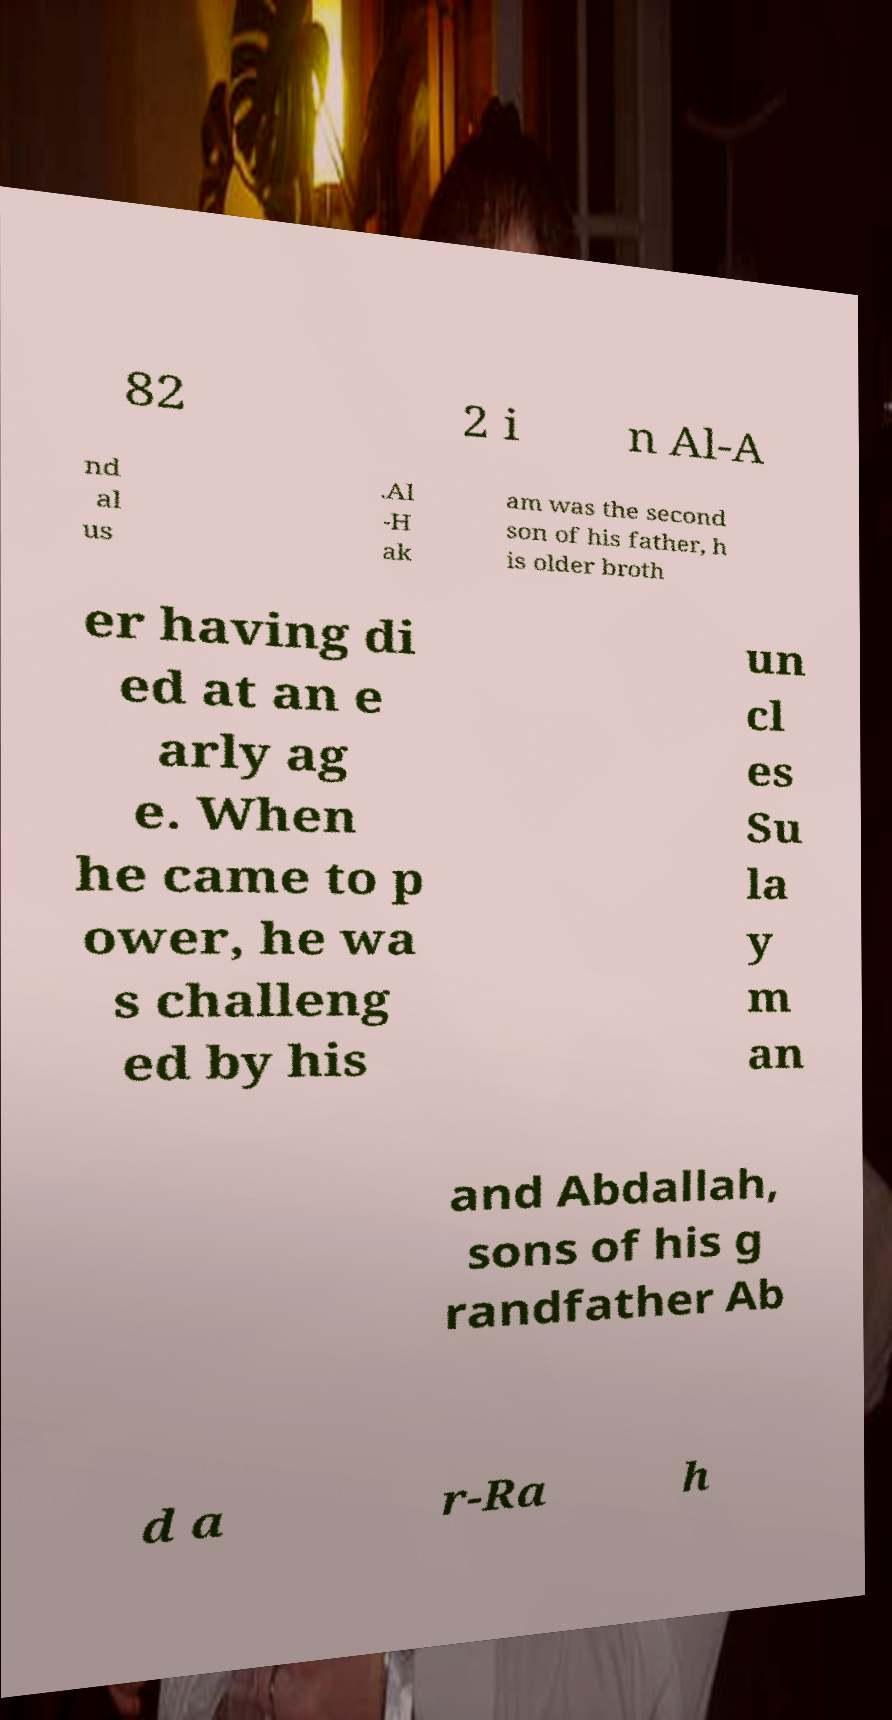Please read and relay the text visible in this image. What does it say? 82 2 i n Al-A nd al us .Al -H ak am was the second son of his father, h is older broth er having di ed at an e arly ag e. When he came to p ower, he wa s challeng ed by his un cl es Su la y m an and Abdallah, sons of his g randfather Ab d a r-Ra h 